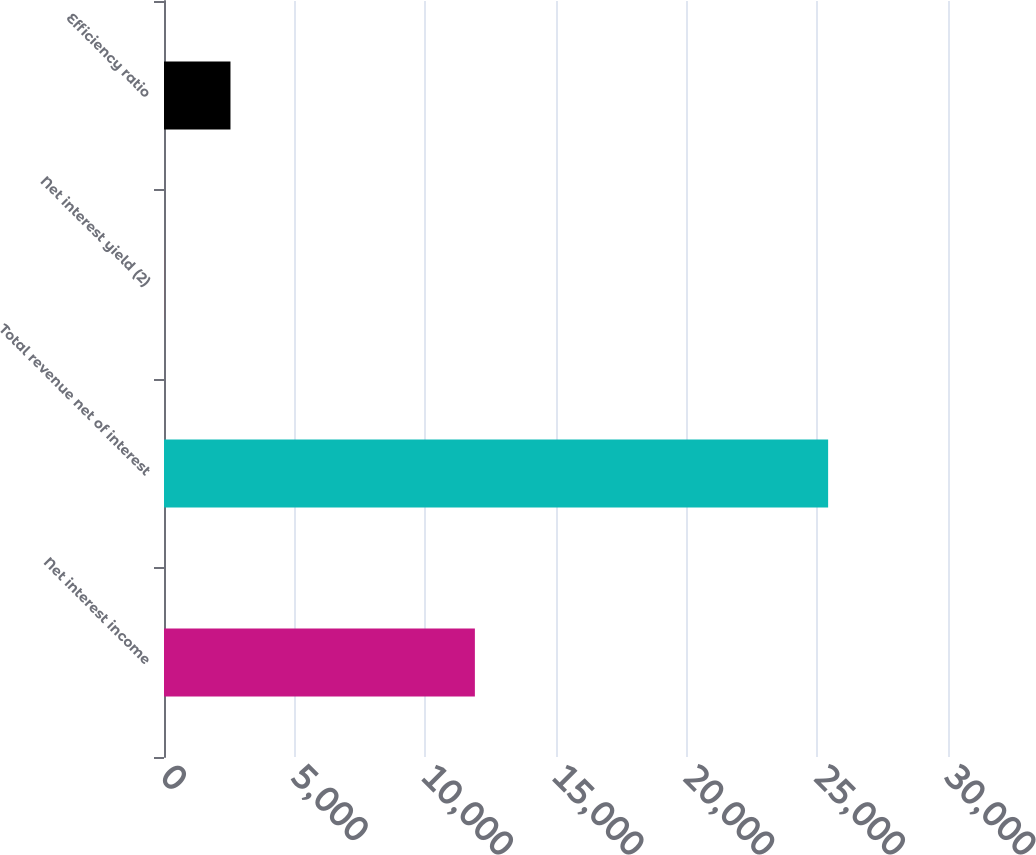Convert chart. <chart><loc_0><loc_0><loc_500><loc_500><bar_chart><fcel>Net interest income<fcel>Total revenue net of interest<fcel>Net interest yield (2)<fcel>Efficiency ratio<nl><fcel>11896<fcel>25413<fcel>2.62<fcel>2543.66<nl></chart> 